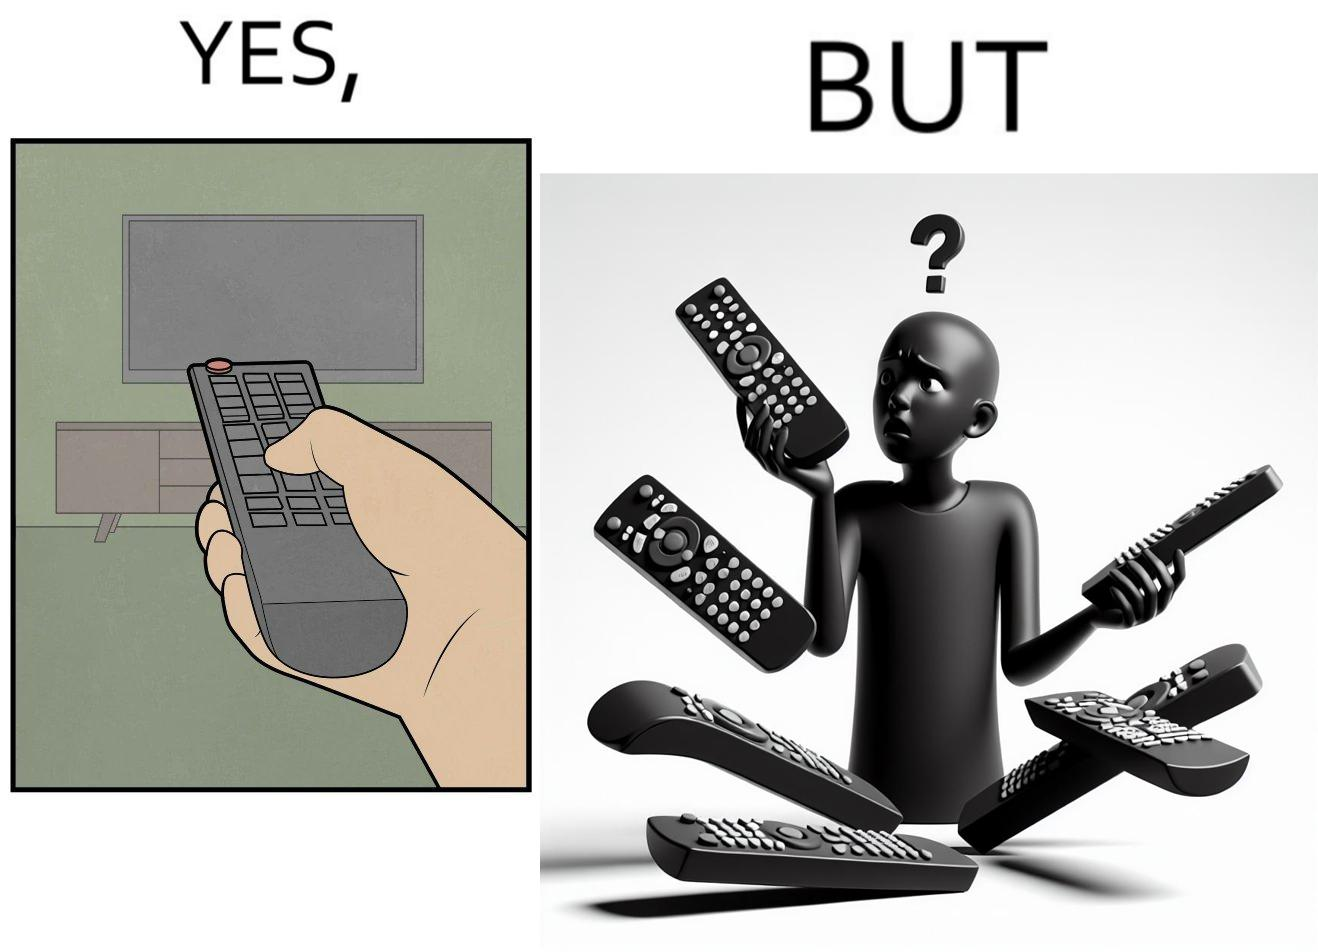Provide a description of this image. The images are funny since they show how even though TV remotes are supposed to make operating TVs easier, having multiple similar looking remotes  for everything only makes it more difficult for the user to use the right one 